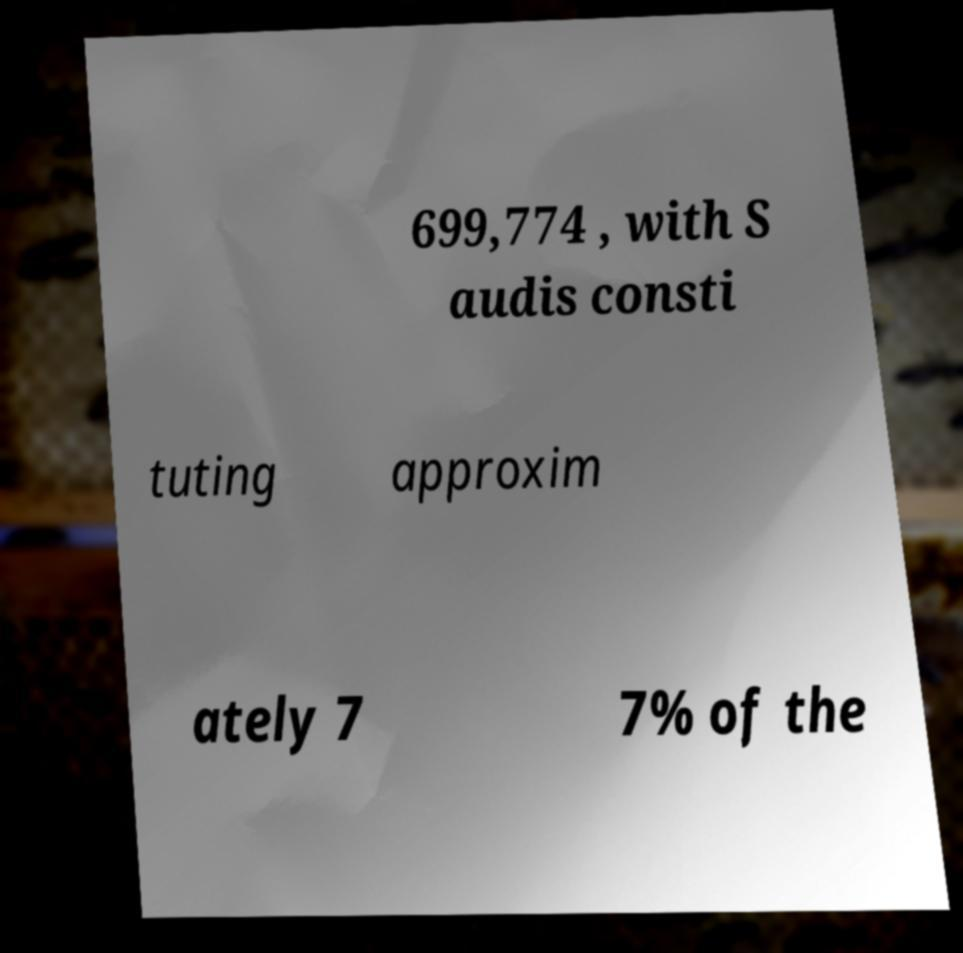There's text embedded in this image that I need extracted. Can you transcribe it verbatim? 699,774 , with S audis consti tuting approxim ately 7 7% of the 